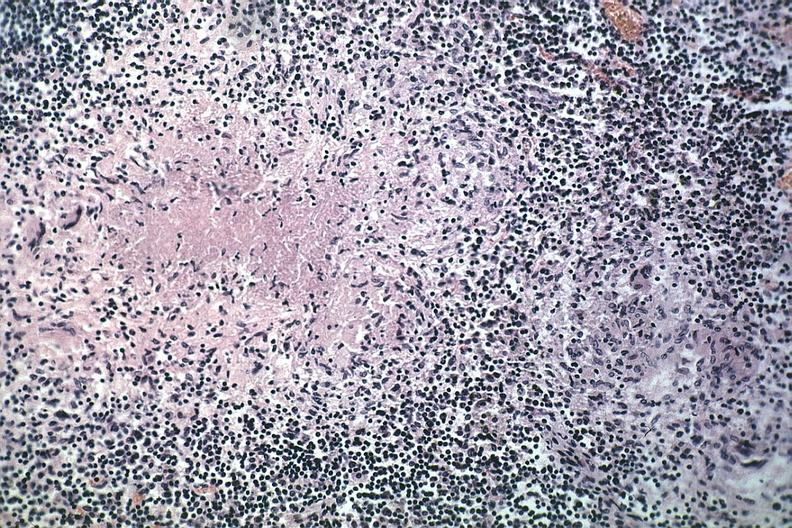does this image show typical area of caseous necrosis with nearby early granuloma quite good source unknown?
Answer the question using a single word or phrase. Yes 